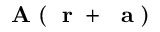Convert formula to latex. <formula><loc_0><loc_0><loc_500><loc_500>A ( r + { a } )</formula> 